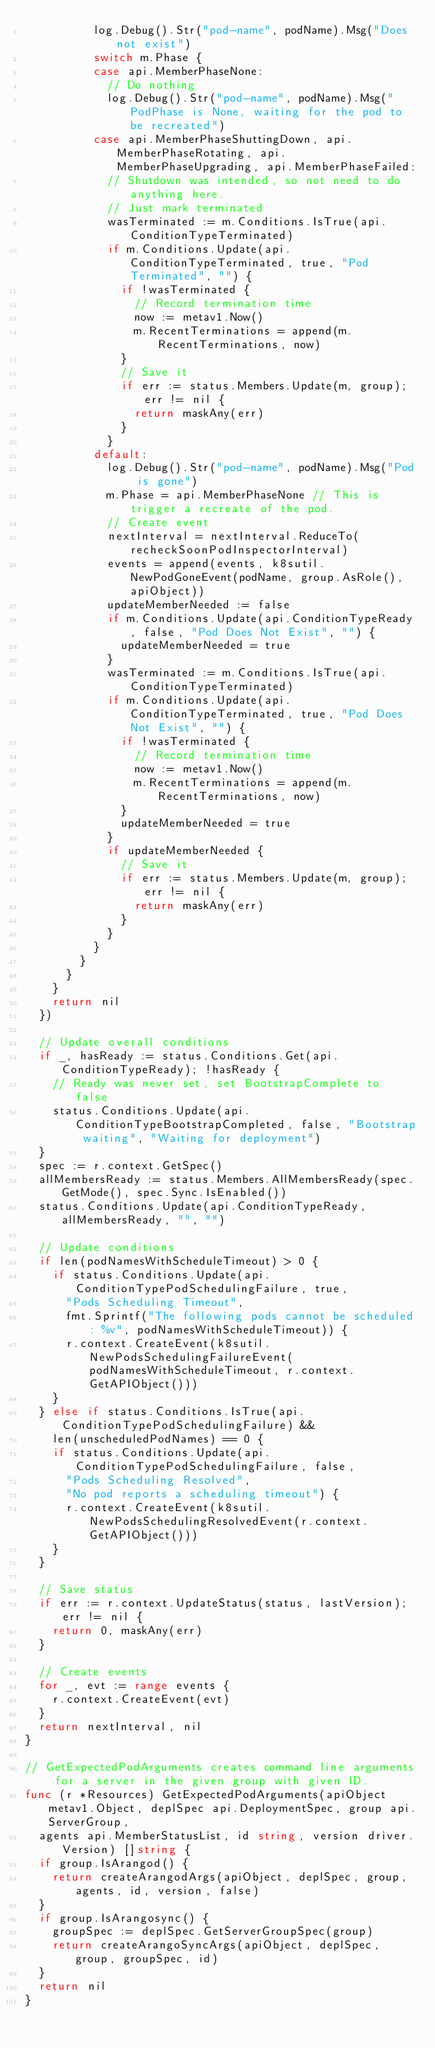Convert code to text. <code><loc_0><loc_0><loc_500><loc_500><_Go_>					log.Debug().Str("pod-name", podName).Msg("Does not exist")
					switch m.Phase {
					case api.MemberPhaseNone:
						// Do nothing
						log.Debug().Str("pod-name", podName).Msg("PodPhase is None, waiting for the pod to be recreated")
					case api.MemberPhaseShuttingDown, api.MemberPhaseRotating, api.MemberPhaseUpgrading, api.MemberPhaseFailed:
						// Shutdown was intended, so not need to do anything here.
						// Just mark terminated
						wasTerminated := m.Conditions.IsTrue(api.ConditionTypeTerminated)
						if m.Conditions.Update(api.ConditionTypeTerminated, true, "Pod Terminated", "") {
							if !wasTerminated {
								// Record termination time
								now := metav1.Now()
								m.RecentTerminations = append(m.RecentTerminations, now)
							}
							// Save it
							if err := status.Members.Update(m, group); err != nil {
								return maskAny(err)
							}
						}
					default:
						log.Debug().Str("pod-name", podName).Msg("Pod is gone")
						m.Phase = api.MemberPhaseNone // This is trigger a recreate of the pod.
						// Create event
						nextInterval = nextInterval.ReduceTo(recheckSoonPodInspectorInterval)
						events = append(events, k8sutil.NewPodGoneEvent(podName, group.AsRole(), apiObject))
						updateMemberNeeded := false
						if m.Conditions.Update(api.ConditionTypeReady, false, "Pod Does Not Exist", "") {
							updateMemberNeeded = true
						}
						wasTerminated := m.Conditions.IsTrue(api.ConditionTypeTerminated)
						if m.Conditions.Update(api.ConditionTypeTerminated, true, "Pod Does Not Exist", "") {
							if !wasTerminated {
								// Record termination time
								now := metav1.Now()
								m.RecentTerminations = append(m.RecentTerminations, now)
							}
							updateMemberNeeded = true
						}
						if updateMemberNeeded {
							// Save it
							if err := status.Members.Update(m, group); err != nil {
								return maskAny(err)
							}
						}
					}
				}
			}
		}
		return nil
	})

	// Update overall conditions
	if _, hasReady := status.Conditions.Get(api.ConditionTypeReady); !hasReady {
		// Ready was never set, set BootstrapComplete to false
		status.Conditions.Update(api.ConditionTypeBootstrapCompleted, false, "Bootstrap waiting", "Waiting for deployment")
	}
	spec := r.context.GetSpec()
	allMembersReady := status.Members.AllMembersReady(spec.GetMode(), spec.Sync.IsEnabled())
	status.Conditions.Update(api.ConditionTypeReady, allMembersReady, "", "")

	// Update conditions
	if len(podNamesWithScheduleTimeout) > 0 {
		if status.Conditions.Update(api.ConditionTypePodSchedulingFailure, true,
			"Pods Scheduling Timeout",
			fmt.Sprintf("The following pods cannot be scheduled: %v", podNamesWithScheduleTimeout)) {
			r.context.CreateEvent(k8sutil.NewPodsSchedulingFailureEvent(podNamesWithScheduleTimeout, r.context.GetAPIObject()))
		}
	} else if status.Conditions.IsTrue(api.ConditionTypePodSchedulingFailure) &&
		len(unscheduledPodNames) == 0 {
		if status.Conditions.Update(api.ConditionTypePodSchedulingFailure, false,
			"Pods Scheduling Resolved",
			"No pod reports a scheduling timeout") {
			r.context.CreateEvent(k8sutil.NewPodsSchedulingResolvedEvent(r.context.GetAPIObject()))
		}
	}

	// Save status
	if err := r.context.UpdateStatus(status, lastVersion); err != nil {
		return 0, maskAny(err)
	}

	// Create events
	for _, evt := range events {
		r.context.CreateEvent(evt)
	}
	return nextInterval, nil
}

// GetExpectedPodArguments creates command line arguments for a server in the given group with given ID.
func (r *Resources) GetExpectedPodArguments(apiObject metav1.Object, deplSpec api.DeploymentSpec, group api.ServerGroup,
	agents api.MemberStatusList, id string, version driver.Version) []string {
	if group.IsArangod() {
		return createArangodArgs(apiObject, deplSpec, group, agents, id, version, false)
	}
	if group.IsArangosync() {
		groupSpec := deplSpec.GetServerGroupSpec(group)
		return createArangoSyncArgs(apiObject, deplSpec, group, groupSpec, id)
	}
	return nil
}
</code> 